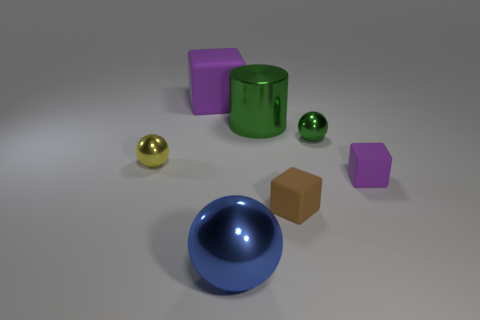What shape is the brown thing that is in front of the small yellow metal ball left of the purple rubber block that is behind the large green cylinder? cube 